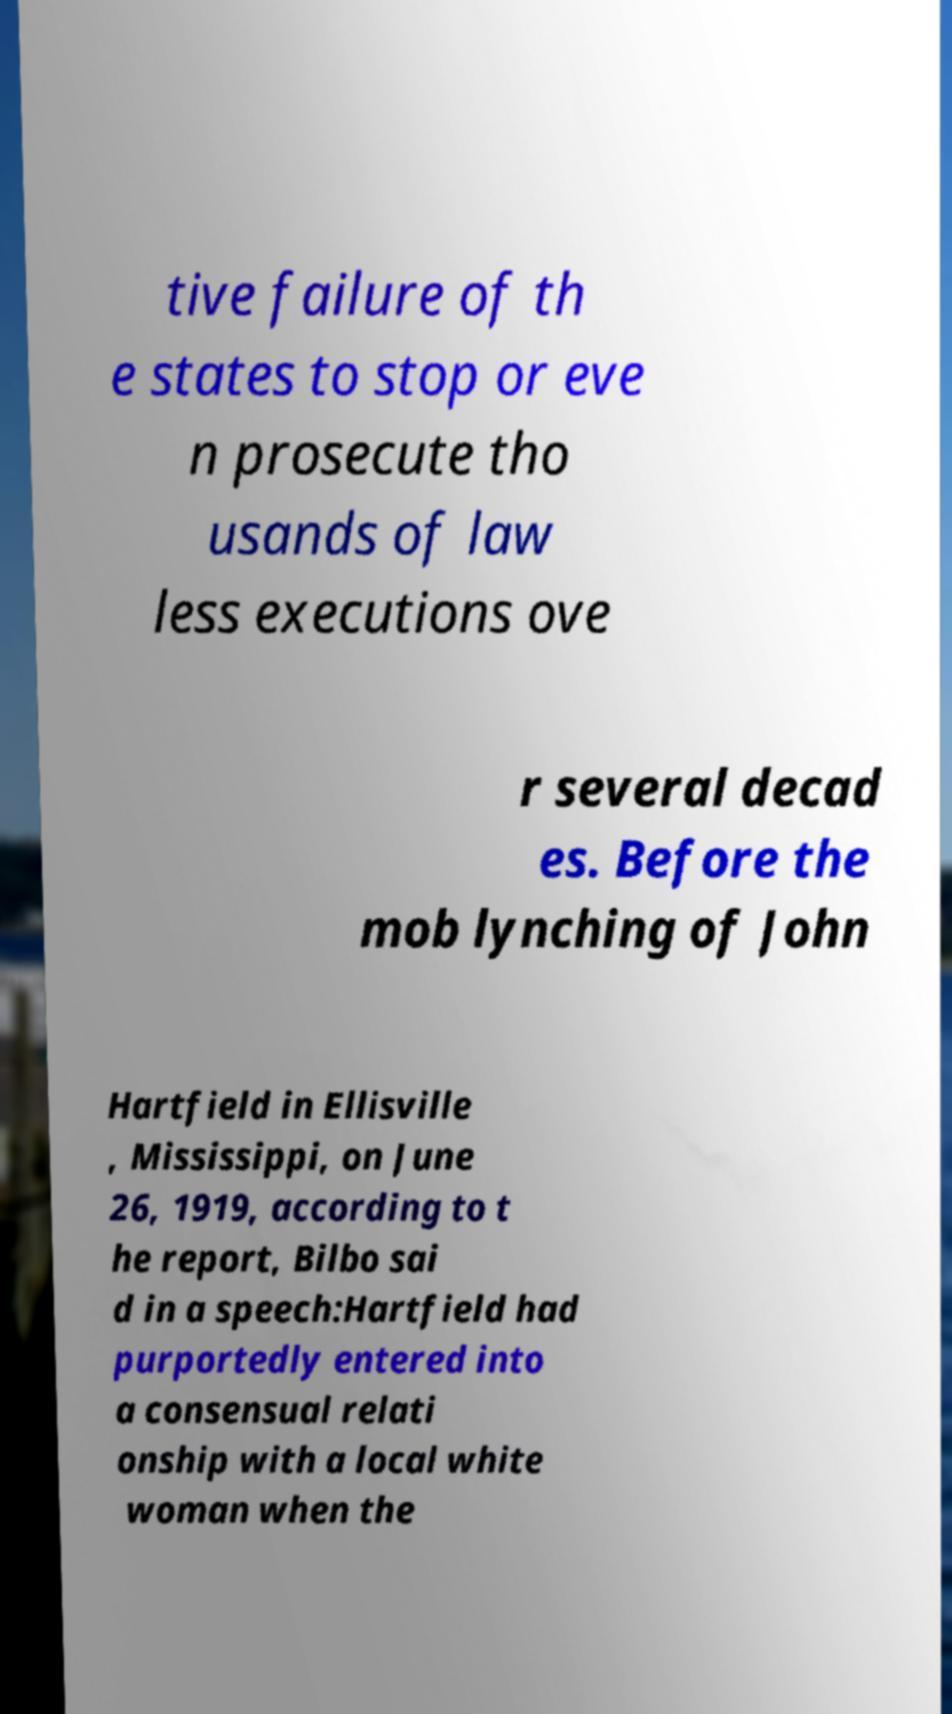Could you assist in decoding the text presented in this image and type it out clearly? tive failure of th e states to stop or eve n prosecute tho usands of law less executions ove r several decad es. Before the mob lynching of John Hartfield in Ellisville , Mississippi, on June 26, 1919, according to t he report, Bilbo sai d in a speech:Hartfield had purportedly entered into a consensual relati onship with a local white woman when the 